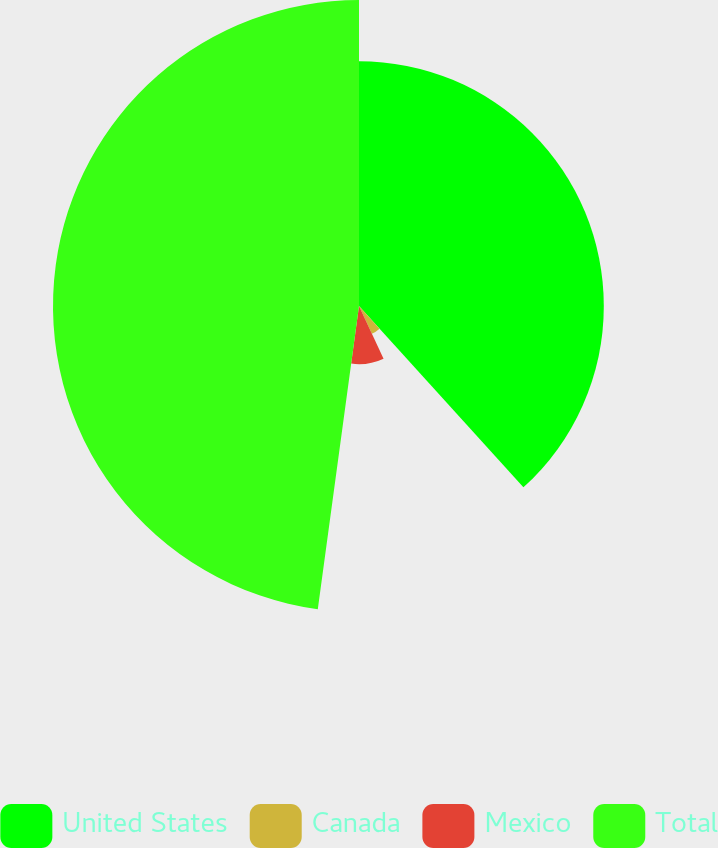Convert chart to OTSL. <chart><loc_0><loc_0><loc_500><loc_500><pie_chart><fcel>United States<fcel>Canada<fcel>Mexico<fcel>Total<nl><fcel>38.28%<fcel>4.78%<fcel>9.09%<fcel>47.85%<nl></chart> 